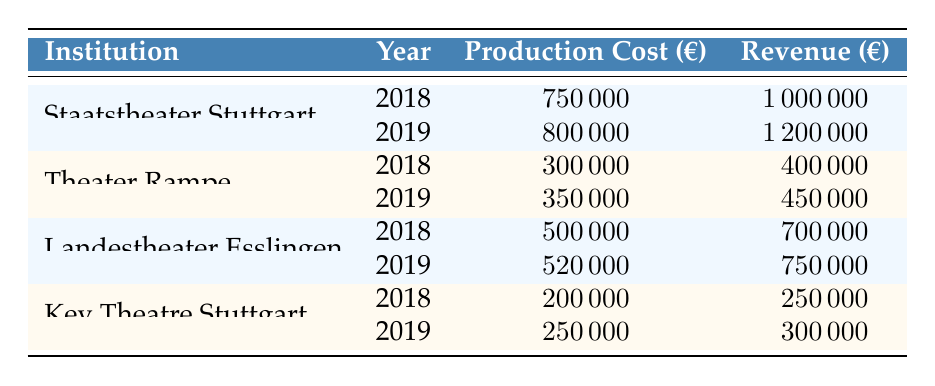What was the production cost for Staatstheater Stuttgart in 2019? Referring to the table, the production cost for Staatstheater Stuttgart specifically for the year 2019 is listed as 800000.
Answer: 800000 What is the revenue for Key Theatre Stuttgart in 2018? According to the table, the revenue for Key Theatre Stuttgart for the year 2018 is recorded as 250000.
Answer: 250000 Which theater had the highest production cost in 2019? By examining the table, Staatstheater Stuttgart shows the highest production cost in 2019, which is 800000.
Answer: Staatstheater Stuttgart What was the total production cost for Theater Rampe over the two years? To find the total production cost for Theater Rampe, we sum the figures for both years: 300000 (2018) + 350000 (2019) = 650000.
Answer: 650000 Did Landestheater Esslingen's revenue increase from 2018 to 2019? Comparing the revenues, Landestheater Esslingen earned 700000 in 2018 and 750000 in 2019, confirming that the revenue increased.
Answer: Yes What was the average production cost across all theaters for the year 2019? Summing the production costs for 2019 gives us: 800000 (Staatstheater Stuttgart) + 350000 (Theater Rampe) + 520000 (Landestheater Esslingen) + 250000 (Key Theatre Stuttgart) = 1925000. Dividing by the four theaters gives an average of 1925000 / 4 = 481250.
Answer: 481250 Was the revenue for Theater Rampe higher than the production cost in both years? Checking the values, Theater Rampe's revenue in 2018 is 400000 (greater than 300000) and in 2019 is 450000 (greater than 350000), confirming it was higher in both years.
Answer: Yes What was the difference in revenue for Staatstheater Stuttgart between 2018 and 2019? The revenue for Staatstheater Stuttgart in 2018 is 1000000 and in 2019 is 1200000. The difference is 1200000 - 1000000 = 200000.
Answer: 200000 What was the total revenue for Key Theatre Stuttgart over the two years? To find the total revenue, we add the 2018 revenue of 250000 and the 2019 revenue of 300000. Thus, 250000 + 300000 = 550000.
Answer: 550000 